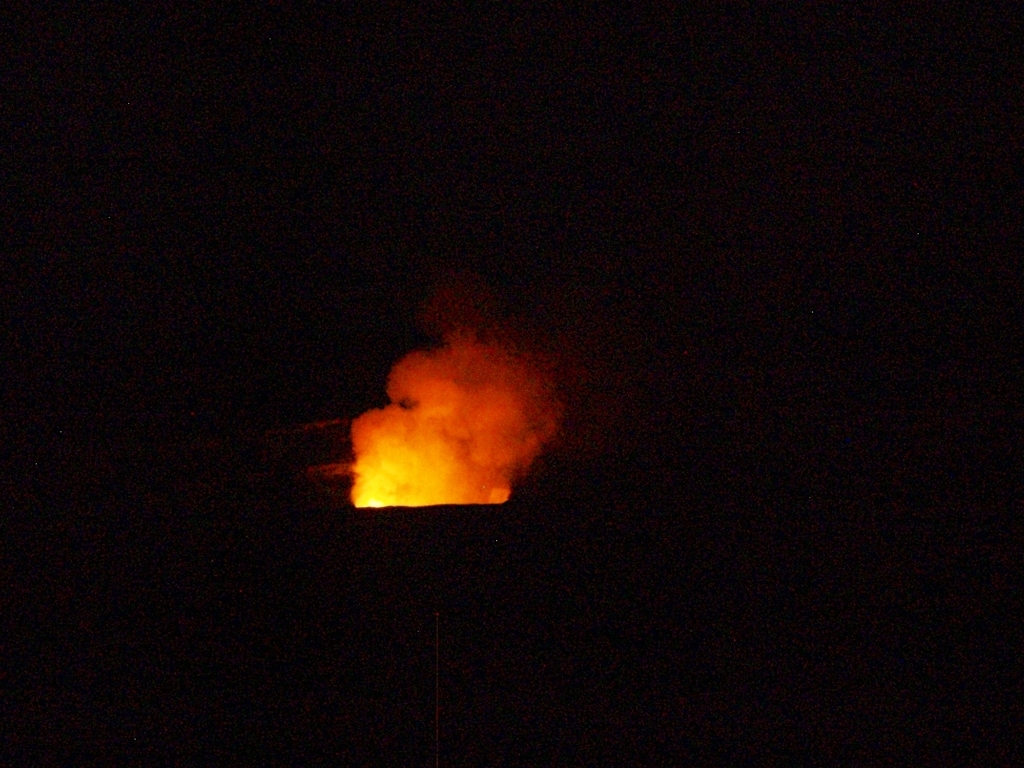Does the poor lighting affect the image quality?
A. Yes
B. No
Answer with the option's letter from the given choices directly.
 A. 